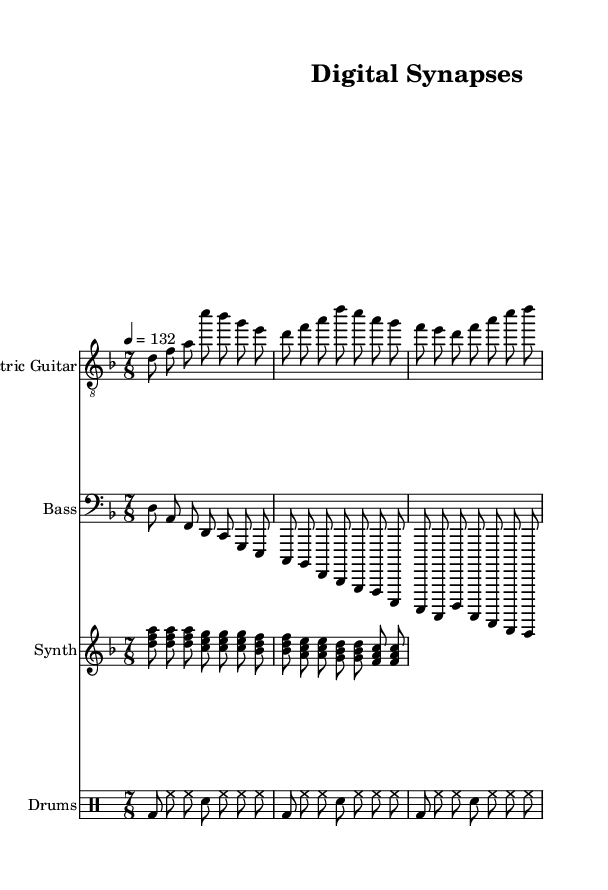What is the key signature of this music? The key signature is D minor, which typically has one flat (B flat) and is indicated on the staff.
Answer: D minor What is the time signature of the piece? The time signature is indicated at the beginning, which shows that there are seven beats per measure, denoted as 7/8.
Answer: 7/8 What is the tempo marking for this piece? The tempo marking indicates the speed of the music, given as 132 beats per minute, generic notation for tempo.
Answer: 132 How many measures are represented in the electric guitar part? There are three measures visible for the electric guitar part, as indicated by the grouping of notes separated by vertical lines.
Answer: 3 What is the main instrumental focus in the provided piece? The presence of electric guitar, bass, synth, and drums suggests that this piece is likely centered around electric guitar sounds typical in Rock music.
Answer: Electric guitar How does the synth part contribute to the overall mood of the music? The lush chords played by the synth section create a layered, atmospheric sound that is often found in progressive rock, emphasizing a technological theme.
Answer: Atmospheric Which drum pattern is featured in this score? The drum pattern consists of a basic rock beat including bass drum and hi-hat, which are aligned with the rhythmic structure typical of rock genres.
Answer: Rock beat 